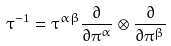<formula> <loc_0><loc_0><loc_500><loc_500>\tau ^ { - 1 } = \tau ^ { \alpha \beta } \frac { \partial } { \partial \pi ^ { \alpha } } \otimes \frac { \partial } { \partial \pi ^ { \beta } }</formula> 